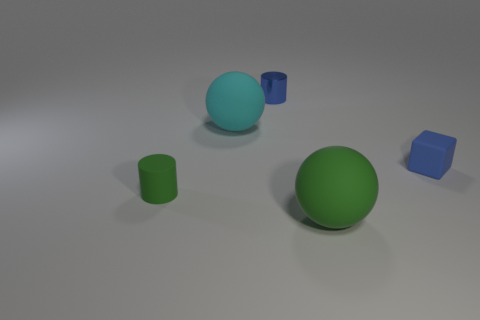Add 5 tiny gray metallic objects. How many objects exist? 10 Subtract all spheres. How many objects are left? 3 Subtract all small blue metal cylinders. Subtract all blue cylinders. How many objects are left? 3 Add 2 blue rubber cubes. How many blue rubber cubes are left? 3 Add 3 rubber balls. How many rubber balls exist? 5 Subtract 0 brown cylinders. How many objects are left? 5 